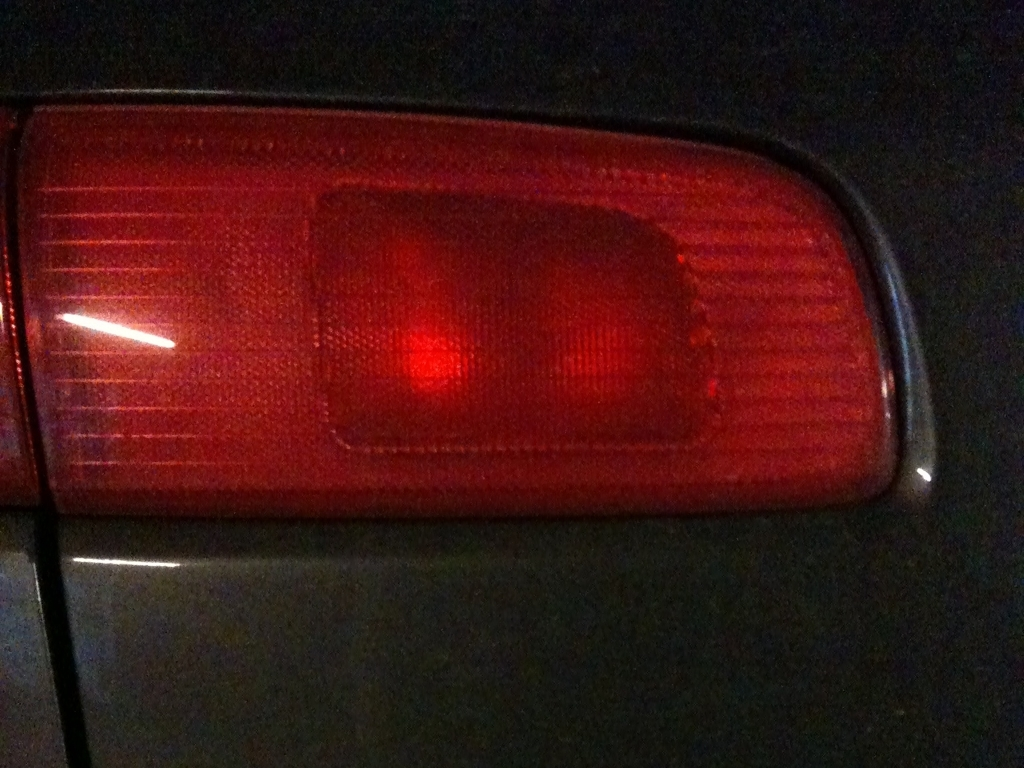What can you tell me about the design of this tail light? This tail light features a red lens, which is standard for indicating brakes and turn signals on vehicles. It has vertical ridges that could serve to diffuse light, improving visibility. The design is utilitarian, likely emphasizing function over style. 